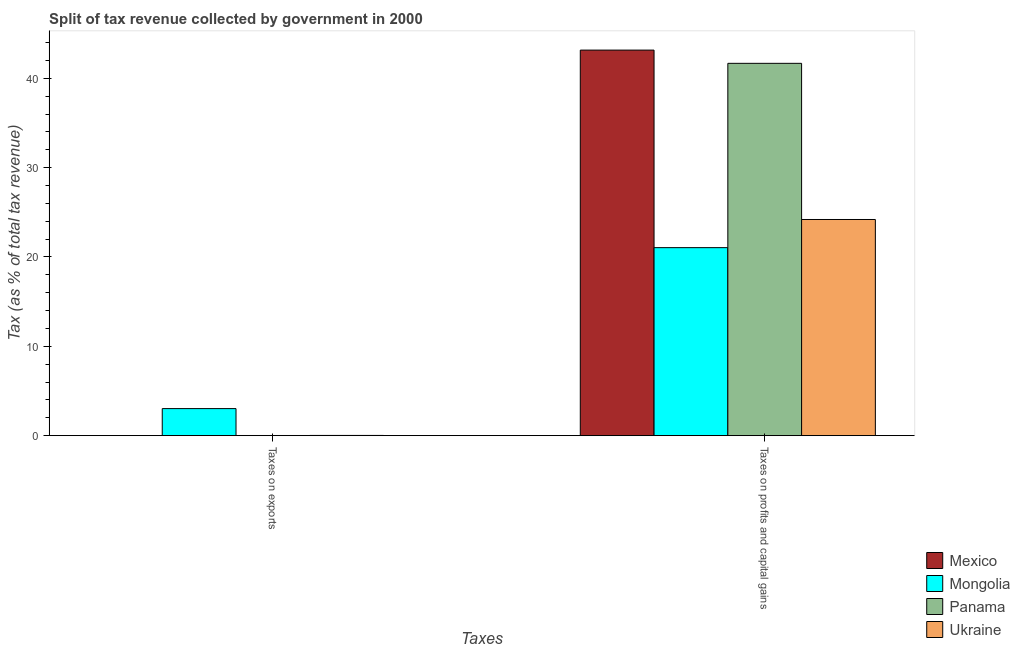Are the number of bars per tick equal to the number of legend labels?
Provide a short and direct response. Yes. How many bars are there on the 2nd tick from the right?
Offer a very short reply. 4. What is the label of the 2nd group of bars from the left?
Provide a short and direct response. Taxes on profits and capital gains. What is the percentage of revenue obtained from taxes on exports in Mongolia?
Offer a very short reply. 3.03. Across all countries, what is the maximum percentage of revenue obtained from taxes on exports?
Keep it short and to the point. 3.03. Across all countries, what is the minimum percentage of revenue obtained from taxes on exports?
Your response must be concise. 0. In which country was the percentage of revenue obtained from taxes on exports minimum?
Your answer should be compact. Mexico. What is the total percentage of revenue obtained from taxes on exports in the graph?
Provide a succinct answer. 3.07. What is the difference between the percentage of revenue obtained from taxes on exports in Mongolia and that in Panama?
Your answer should be compact. 3.01. What is the difference between the percentage of revenue obtained from taxes on profits and capital gains in Mongolia and the percentage of revenue obtained from taxes on exports in Panama?
Provide a succinct answer. 21.03. What is the average percentage of revenue obtained from taxes on exports per country?
Provide a succinct answer. 0.77. What is the difference between the percentage of revenue obtained from taxes on profits and capital gains and percentage of revenue obtained from taxes on exports in Mexico?
Your answer should be very brief. 43.16. What is the ratio of the percentage of revenue obtained from taxes on exports in Panama to that in Ukraine?
Make the answer very short. 0.72. What does the 4th bar from the left in Taxes on exports represents?
Provide a short and direct response. Ukraine. What does the 3rd bar from the right in Taxes on profits and capital gains represents?
Your answer should be compact. Mongolia. Where does the legend appear in the graph?
Keep it short and to the point. Bottom right. How many legend labels are there?
Provide a short and direct response. 4. How are the legend labels stacked?
Ensure brevity in your answer.  Vertical. What is the title of the graph?
Offer a terse response. Split of tax revenue collected by government in 2000. Does "Zambia" appear as one of the legend labels in the graph?
Your answer should be compact. No. What is the label or title of the X-axis?
Give a very brief answer. Taxes. What is the label or title of the Y-axis?
Offer a terse response. Tax (as % of total tax revenue). What is the Tax (as % of total tax revenue) in Mexico in Taxes on exports?
Offer a very short reply. 0. What is the Tax (as % of total tax revenue) in Mongolia in Taxes on exports?
Keep it short and to the point. 3.03. What is the Tax (as % of total tax revenue) of Panama in Taxes on exports?
Provide a succinct answer. 0.02. What is the Tax (as % of total tax revenue) of Ukraine in Taxes on exports?
Offer a terse response. 0.02. What is the Tax (as % of total tax revenue) in Mexico in Taxes on profits and capital gains?
Make the answer very short. 43.16. What is the Tax (as % of total tax revenue) of Mongolia in Taxes on profits and capital gains?
Provide a succinct answer. 21.04. What is the Tax (as % of total tax revenue) in Panama in Taxes on profits and capital gains?
Provide a succinct answer. 41.68. What is the Tax (as % of total tax revenue) in Ukraine in Taxes on profits and capital gains?
Ensure brevity in your answer.  24.2. Across all Taxes, what is the maximum Tax (as % of total tax revenue) in Mexico?
Your answer should be very brief. 43.16. Across all Taxes, what is the maximum Tax (as % of total tax revenue) in Mongolia?
Your answer should be very brief. 21.04. Across all Taxes, what is the maximum Tax (as % of total tax revenue) of Panama?
Offer a terse response. 41.68. Across all Taxes, what is the maximum Tax (as % of total tax revenue) in Ukraine?
Provide a succinct answer. 24.2. Across all Taxes, what is the minimum Tax (as % of total tax revenue) in Mexico?
Make the answer very short. 0. Across all Taxes, what is the minimum Tax (as % of total tax revenue) of Mongolia?
Offer a very short reply. 3.03. Across all Taxes, what is the minimum Tax (as % of total tax revenue) of Panama?
Make the answer very short. 0.02. Across all Taxes, what is the minimum Tax (as % of total tax revenue) in Ukraine?
Your response must be concise. 0.02. What is the total Tax (as % of total tax revenue) of Mexico in the graph?
Ensure brevity in your answer.  43.16. What is the total Tax (as % of total tax revenue) of Mongolia in the graph?
Provide a short and direct response. 24.07. What is the total Tax (as % of total tax revenue) in Panama in the graph?
Provide a short and direct response. 41.69. What is the total Tax (as % of total tax revenue) in Ukraine in the graph?
Provide a short and direct response. 24.22. What is the difference between the Tax (as % of total tax revenue) in Mexico in Taxes on exports and that in Taxes on profits and capital gains?
Your response must be concise. -43.16. What is the difference between the Tax (as % of total tax revenue) of Mongolia in Taxes on exports and that in Taxes on profits and capital gains?
Your response must be concise. -18.02. What is the difference between the Tax (as % of total tax revenue) in Panama in Taxes on exports and that in Taxes on profits and capital gains?
Offer a very short reply. -41.66. What is the difference between the Tax (as % of total tax revenue) of Ukraine in Taxes on exports and that in Taxes on profits and capital gains?
Your answer should be compact. -24.17. What is the difference between the Tax (as % of total tax revenue) in Mexico in Taxes on exports and the Tax (as % of total tax revenue) in Mongolia in Taxes on profits and capital gains?
Give a very brief answer. -21.04. What is the difference between the Tax (as % of total tax revenue) of Mexico in Taxes on exports and the Tax (as % of total tax revenue) of Panama in Taxes on profits and capital gains?
Keep it short and to the point. -41.68. What is the difference between the Tax (as % of total tax revenue) of Mexico in Taxes on exports and the Tax (as % of total tax revenue) of Ukraine in Taxes on profits and capital gains?
Offer a terse response. -24.2. What is the difference between the Tax (as % of total tax revenue) in Mongolia in Taxes on exports and the Tax (as % of total tax revenue) in Panama in Taxes on profits and capital gains?
Offer a very short reply. -38.65. What is the difference between the Tax (as % of total tax revenue) of Mongolia in Taxes on exports and the Tax (as % of total tax revenue) of Ukraine in Taxes on profits and capital gains?
Make the answer very short. -21.17. What is the difference between the Tax (as % of total tax revenue) in Panama in Taxes on exports and the Tax (as % of total tax revenue) in Ukraine in Taxes on profits and capital gains?
Keep it short and to the point. -24.18. What is the average Tax (as % of total tax revenue) of Mexico per Taxes?
Keep it short and to the point. 21.58. What is the average Tax (as % of total tax revenue) of Mongolia per Taxes?
Give a very brief answer. 12.04. What is the average Tax (as % of total tax revenue) of Panama per Taxes?
Ensure brevity in your answer.  20.85. What is the average Tax (as % of total tax revenue) of Ukraine per Taxes?
Provide a succinct answer. 12.11. What is the difference between the Tax (as % of total tax revenue) in Mexico and Tax (as % of total tax revenue) in Mongolia in Taxes on exports?
Make the answer very short. -3.03. What is the difference between the Tax (as % of total tax revenue) in Mexico and Tax (as % of total tax revenue) in Panama in Taxes on exports?
Provide a succinct answer. -0.02. What is the difference between the Tax (as % of total tax revenue) in Mexico and Tax (as % of total tax revenue) in Ukraine in Taxes on exports?
Provide a short and direct response. -0.02. What is the difference between the Tax (as % of total tax revenue) of Mongolia and Tax (as % of total tax revenue) of Panama in Taxes on exports?
Keep it short and to the point. 3.01. What is the difference between the Tax (as % of total tax revenue) in Mongolia and Tax (as % of total tax revenue) in Ukraine in Taxes on exports?
Keep it short and to the point. 3. What is the difference between the Tax (as % of total tax revenue) in Panama and Tax (as % of total tax revenue) in Ukraine in Taxes on exports?
Ensure brevity in your answer.  -0.01. What is the difference between the Tax (as % of total tax revenue) in Mexico and Tax (as % of total tax revenue) in Mongolia in Taxes on profits and capital gains?
Your response must be concise. 22.11. What is the difference between the Tax (as % of total tax revenue) in Mexico and Tax (as % of total tax revenue) in Panama in Taxes on profits and capital gains?
Provide a short and direct response. 1.48. What is the difference between the Tax (as % of total tax revenue) of Mexico and Tax (as % of total tax revenue) of Ukraine in Taxes on profits and capital gains?
Provide a succinct answer. 18.96. What is the difference between the Tax (as % of total tax revenue) of Mongolia and Tax (as % of total tax revenue) of Panama in Taxes on profits and capital gains?
Your answer should be compact. -20.63. What is the difference between the Tax (as % of total tax revenue) of Mongolia and Tax (as % of total tax revenue) of Ukraine in Taxes on profits and capital gains?
Offer a terse response. -3.15. What is the difference between the Tax (as % of total tax revenue) in Panama and Tax (as % of total tax revenue) in Ukraine in Taxes on profits and capital gains?
Give a very brief answer. 17.48. What is the ratio of the Tax (as % of total tax revenue) of Mexico in Taxes on exports to that in Taxes on profits and capital gains?
Make the answer very short. 0. What is the ratio of the Tax (as % of total tax revenue) in Mongolia in Taxes on exports to that in Taxes on profits and capital gains?
Keep it short and to the point. 0.14. What is the ratio of the Tax (as % of total tax revenue) in Panama in Taxes on exports to that in Taxes on profits and capital gains?
Provide a succinct answer. 0. What is the difference between the highest and the second highest Tax (as % of total tax revenue) in Mexico?
Offer a terse response. 43.16. What is the difference between the highest and the second highest Tax (as % of total tax revenue) in Mongolia?
Provide a succinct answer. 18.02. What is the difference between the highest and the second highest Tax (as % of total tax revenue) of Panama?
Make the answer very short. 41.66. What is the difference between the highest and the second highest Tax (as % of total tax revenue) of Ukraine?
Provide a succinct answer. 24.17. What is the difference between the highest and the lowest Tax (as % of total tax revenue) in Mexico?
Provide a succinct answer. 43.16. What is the difference between the highest and the lowest Tax (as % of total tax revenue) in Mongolia?
Ensure brevity in your answer.  18.02. What is the difference between the highest and the lowest Tax (as % of total tax revenue) of Panama?
Provide a short and direct response. 41.66. What is the difference between the highest and the lowest Tax (as % of total tax revenue) of Ukraine?
Offer a terse response. 24.17. 